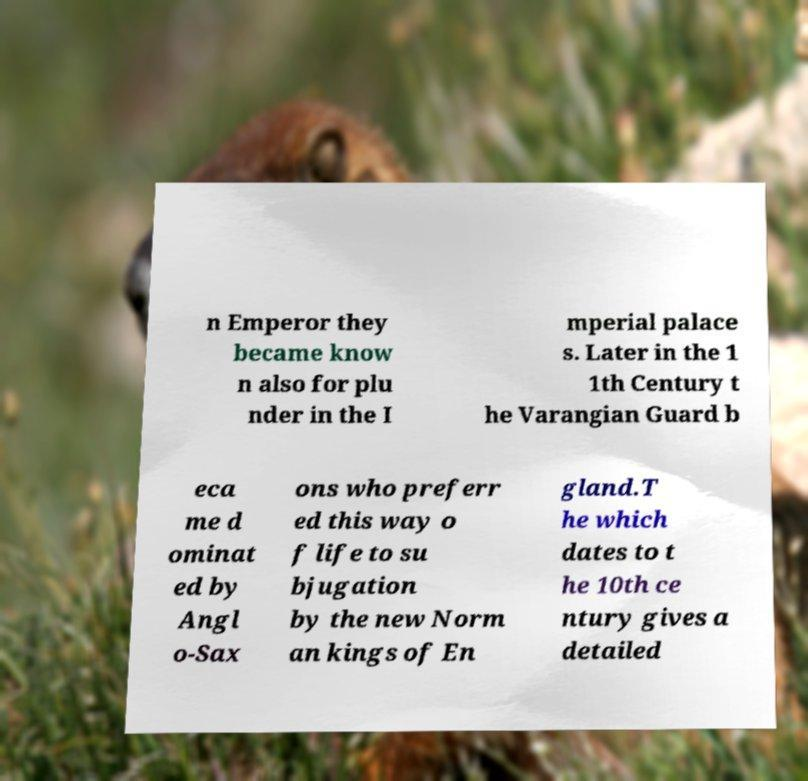Please identify and transcribe the text found in this image. n Emperor they became know n also for plu nder in the I mperial palace s. Later in the 1 1th Century t he Varangian Guard b eca me d ominat ed by Angl o-Sax ons who preferr ed this way o f life to su bjugation by the new Norm an kings of En gland.T he which dates to t he 10th ce ntury gives a detailed 